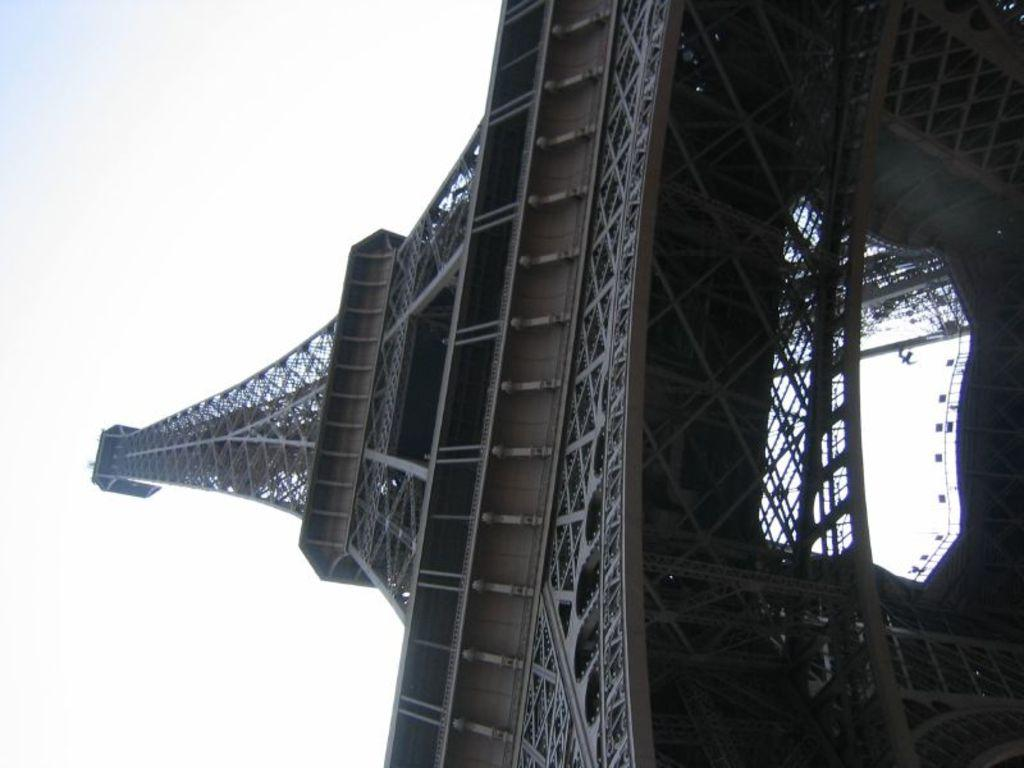What famous landmark can be seen in the image? There is an Eiffel tower in the image. What part of the natural environment is visible in the image? The sky is visible in the image. What type of insurance is being discussed in the image? There is no discussion of insurance in the image, as it features the Eiffel tower and the sky. 